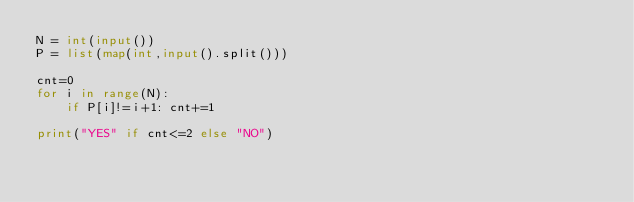Convert code to text. <code><loc_0><loc_0><loc_500><loc_500><_Python_>N = int(input())
P = list(map(int,input().split()))

cnt=0
for i in range(N):
    if P[i]!=i+1: cnt+=1

print("YES" if cnt<=2 else "NO")</code> 